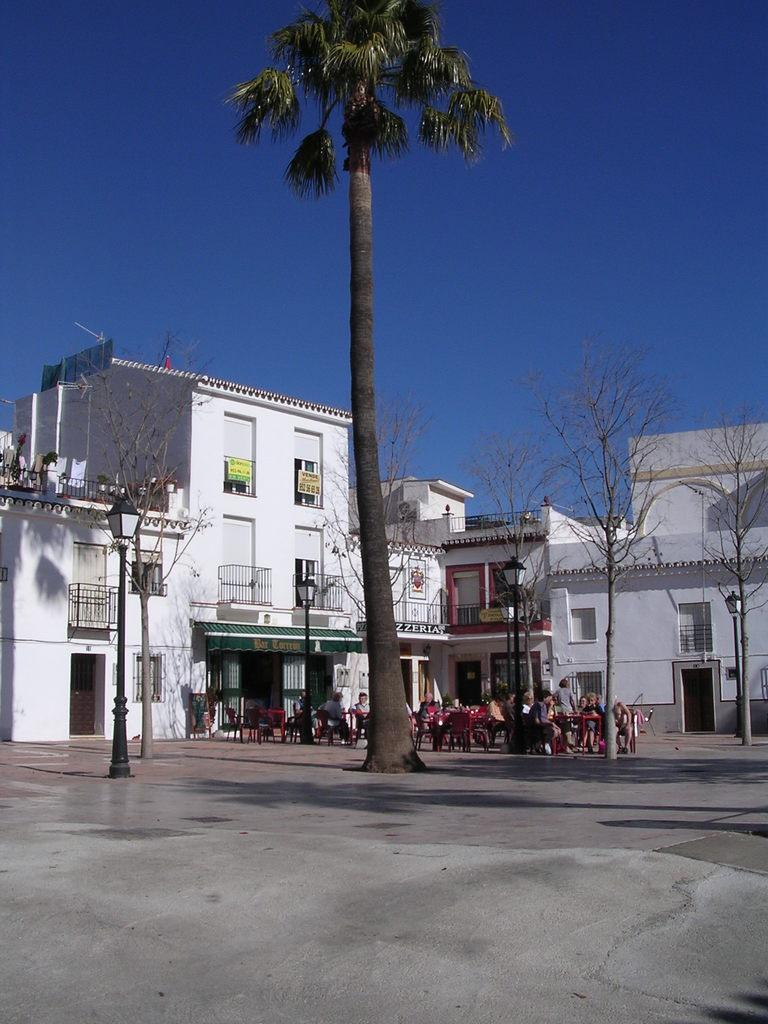What is the main subject in the middle of the image? There is a tall tree in the middle of the image. What can be seen in the background of the image? There are houses and trees in the background of the image. Are there any people visible in the image? Yes, there are people sitting on chairs in the background of the image. What type of jewel is hanging from the tall tree in the image? There is no jewel hanging from the tall tree in the image; it is a tree in a natural setting. 